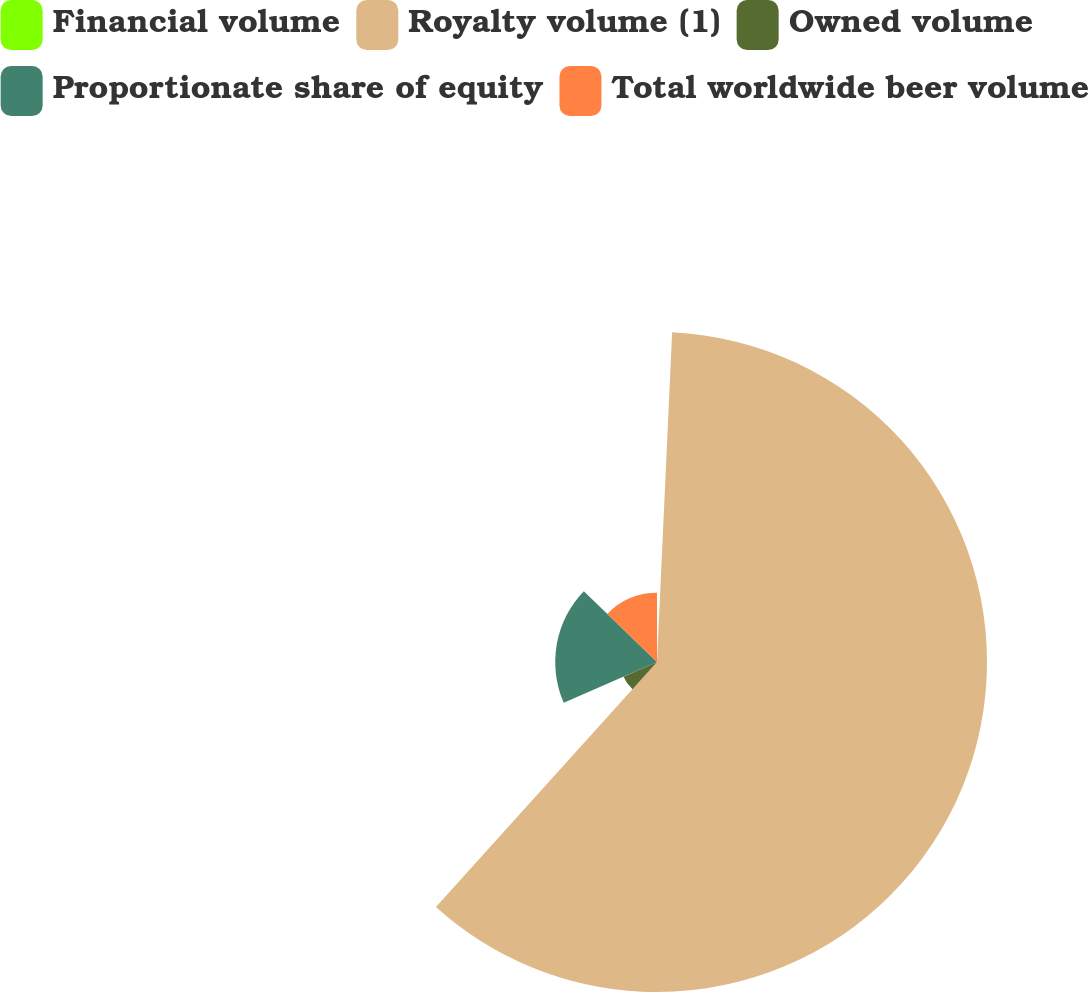Convert chart. <chart><loc_0><loc_0><loc_500><loc_500><pie_chart><fcel>Financial volume<fcel>Royalty volume (1)<fcel>Owned volume<fcel>Proportionate share of equity<fcel>Total worldwide beer volume<nl><fcel>0.73%<fcel>60.96%<fcel>6.75%<fcel>18.8%<fcel>12.77%<nl></chart> 